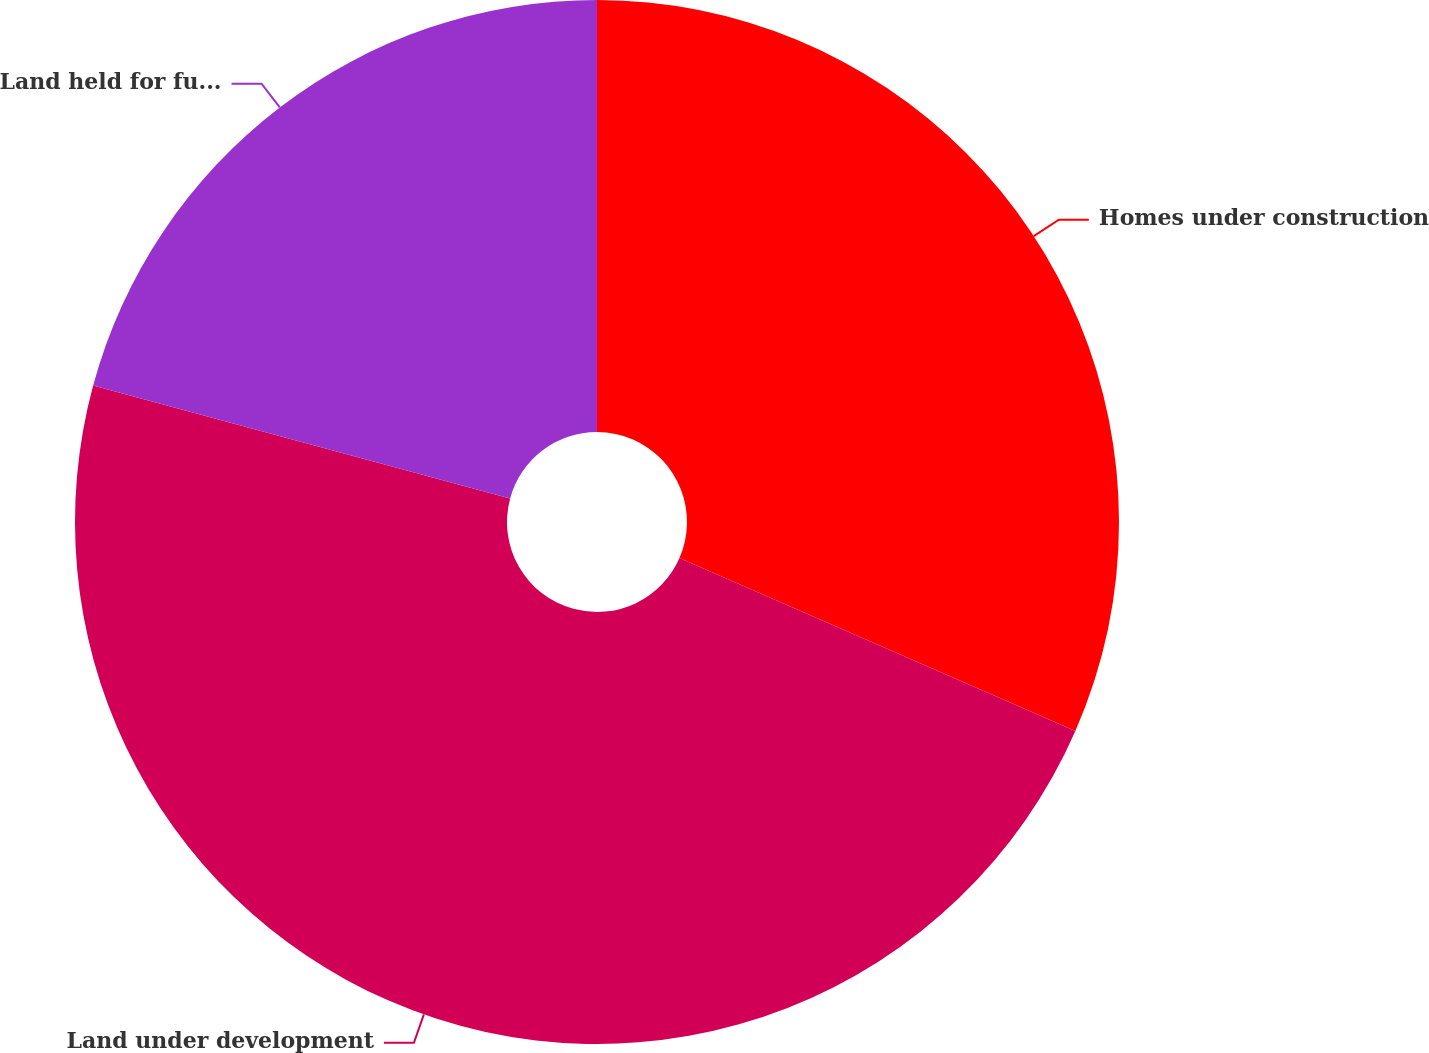Convert chart. <chart><loc_0><loc_0><loc_500><loc_500><pie_chart><fcel>Homes under construction<fcel>Land under development<fcel>Land held for future<nl><fcel>31.55%<fcel>47.65%<fcel>20.79%<nl></chart> 